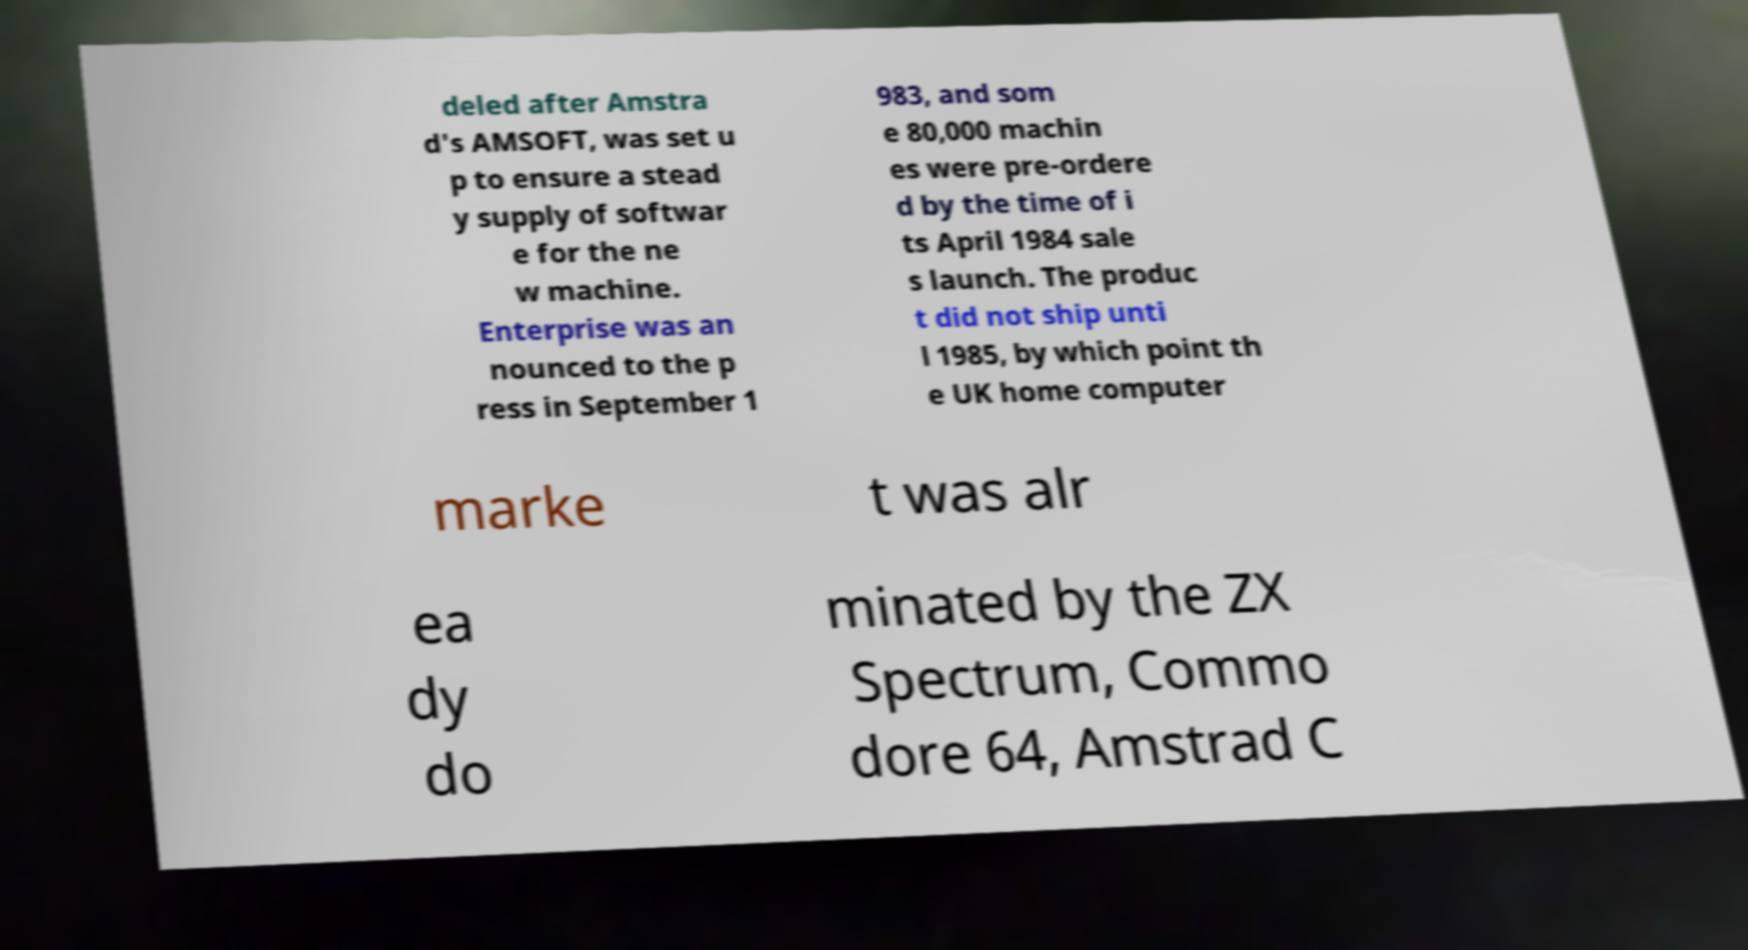Could you assist in decoding the text presented in this image and type it out clearly? deled after Amstra d's AMSOFT, was set u p to ensure a stead y supply of softwar e for the ne w machine. Enterprise was an nounced to the p ress in September 1 983, and som e 80,000 machin es were pre-ordere d by the time of i ts April 1984 sale s launch. The produc t did not ship unti l 1985, by which point th e UK home computer marke t was alr ea dy do minated by the ZX Spectrum, Commo dore 64, Amstrad C 